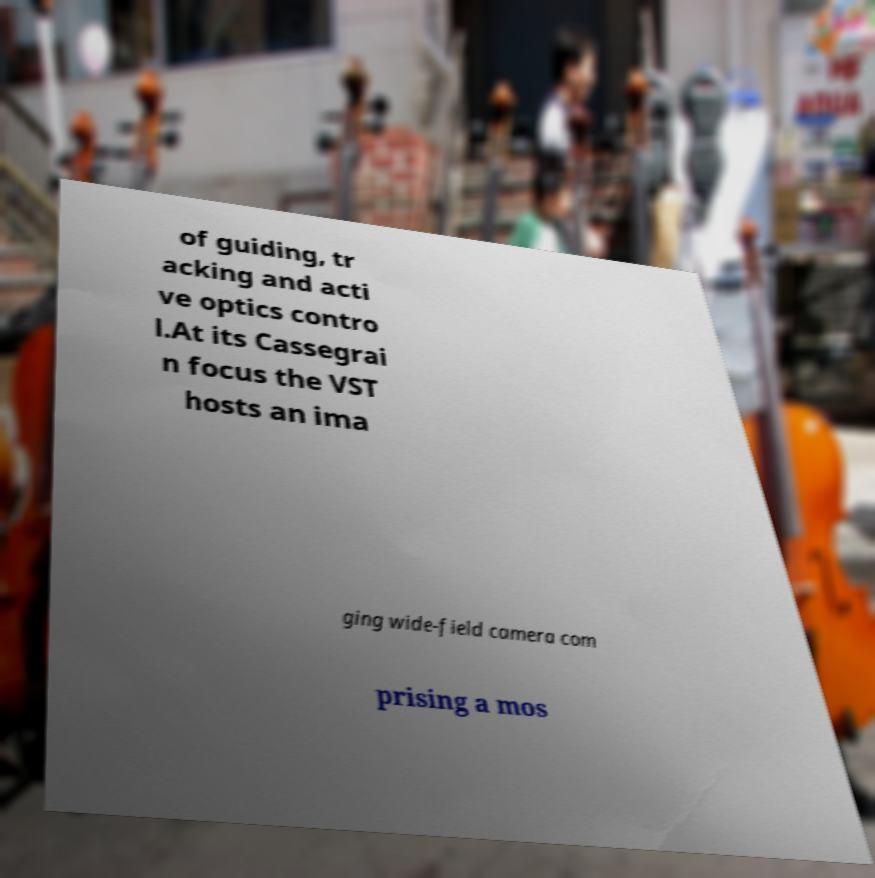Please read and relay the text visible in this image. What does it say? of guiding, tr acking and acti ve optics contro l.At its Cassegrai n focus the VST hosts an ima ging wide-field camera com prising a mos 